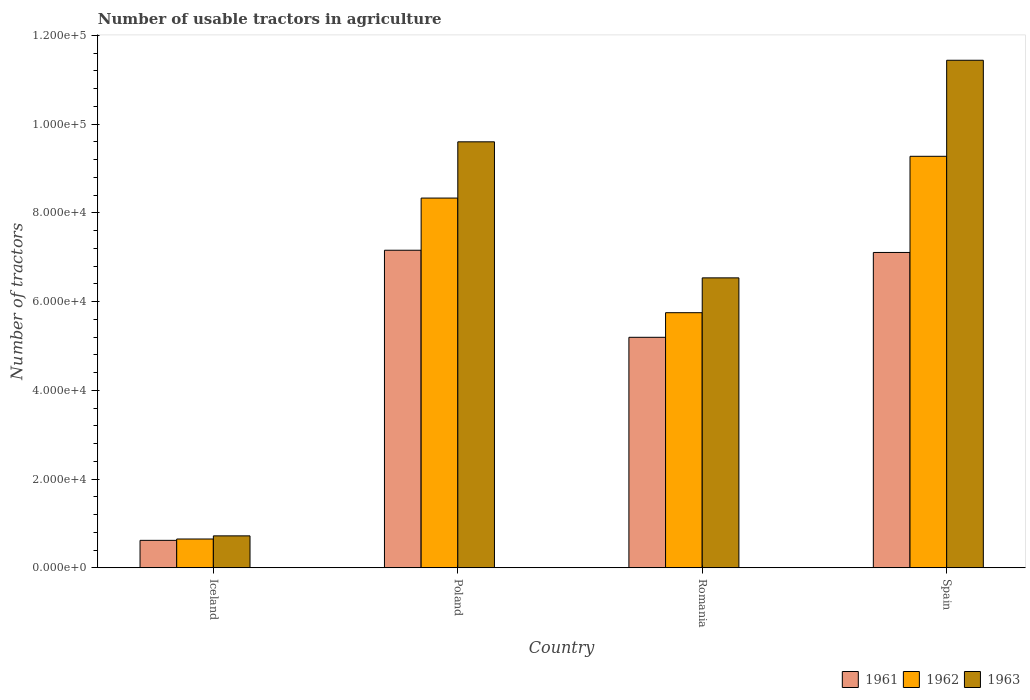How many different coloured bars are there?
Your response must be concise. 3. Are the number of bars per tick equal to the number of legend labels?
Offer a terse response. Yes. What is the label of the 4th group of bars from the left?
Provide a short and direct response. Spain. In how many cases, is the number of bars for a given country not equal to the number of legend labels?
Provide a succinct answer. 0. What is the number of usable tractors in agriculture in 1961 in Poland?
Make the answer very short. 7.16e+04. Across all countries, what is the maximum number of usable tractors in agriculture in 1961?
Your answer should be compact. 7.16e+04. Across all countries, what is the minimum number of usable tractors in agriculture in 1963?
Your response must be concise. 7187. In which country was the number of usable tractors in agriculture in 1961 maximum?
Give a very brief answer. Poland. In which country was the number of usable tractors in agriculture in 1962 minimum?
Your answer should be very brief. Iceland. What is the total number of usable tractors in agriculture in 1962 in the graph?
Offer a terse response. 2.40e+05. What is the difference between the number of usable tractors in agriculture in 1961 in Iceland and that in Romania?
Make the answer very short. -4.58e+04. What is the difference between the number of usable tractors in agriculture in 1961 in Spain and the number of usable tractors in agriculture in 1963 in Romania?
Your answer should be compact. 5726. What is the average number of usable tractors in agriculture in 1961 per country?
Offer a very short reply. 5.02e+04. What is the difference between the number of usable tractors in agriculture of/in 1963 and number of usable tractors in agriculture of/in 1962 in Poland?
Offer a terse response. 1.27e+04. In how many countries, is the number of usable tractors in agriculture in 1961 greater than 44000?
Ensure brevity in your answer.  3. What is the ratio of the number of usable tractors in agriculture in 1961 in Iceland to that in Poland?
Offer a very short reply. 0.09. Is the difference between the number of usable tractors in agriculture in 1963 in Romania and Spain greater than the difference between the number of usable tractors in agriculture in 1962 in Romania and Spain?
Offer a terse response. No. What is the difference between the highest and the second highest number of usable tractors in agriculture in 1963?
Your answer should be very brief. 1.84e+04. What is the difference between the highest and the lowest number of usable tractors in agriculture in 1962?
Provide a short and direct response. 8.63e+04. In how many countries, is the number of usable tractors in agriculture in 1961 greater than the average number of usable tractors in agriculture in 1961 taken over all countries?
Provide a short and direct response. 3. What is the difference between two consecutive major ticks on the Y-axis?
Offer a very short reply. 2.00e+04. Does the graph contain any zero values?
Make the answer very short. No. Does the graph contain grids?
Ensure brevity in your answer.  No. Where does the legend appear in the graph?
Give a very brief answer. Bottom right. What is the title of the graph?
Give a very brief answer. Number of usable tractors in agriculture. What is the label or title of the X-axis?
Provide a succinct answer. Country. What is the label or title of the Y-axis?
Your answer should be very brief. Number of tractors. What is the Number of tractors in 1961 in Iceland?
Keep it short and to the point. 6177. What is the Number of tractors in 1962 in Iceland?
Your answer should be very brief. 6479. What is the Number of tractors of 1963 in Iceland?
Make the answer very short. 7187. What is the Number of tractors of 1961 in Poland?
Give a very brief answer. 7.16e+04. What is the Number of tractors in 1962 in Poland?
Provide a succinct answer. 8.33e+04. What is the Number of tractors in 1963 in Poland?
Your response must be concise. 9.60e+04. What is the Number of tractors of 1961 in Romania?
Provide a succinct answer. 5.20e+04. What is the Number of tractors in 1962 in Romania?
Offer a terse response. 5.75e+04. What is the Number of tractors in 1963 in Romania?
Keep it short and to the point. 6.54e+04. What is the Number of tractors in 1961 in Spain?
Provide a succinct answer. 7.11e+04. What is the Number of tractors in 1962 in Spain?
Your answer should be very brief. 9.28e+04. What is the Number of tractors of 1963 in Spain?
Your answer should be very brief. 1.14e+05. Across all countries, what is the maximum Number of tractors in 1961?
Make the answer very short. 7.16e+04. Across all countries, what is the maximum Number of tractors in 1962?
Provide a succinct answer. 9.28e+04. Across all countries, what is the maximum Number of tractors in 1963?
Provide a short and direct response. 1.14e+05. Across all countries, what is the minimum Number of tractors in 1961?
Offer a terse response. 6177. Across all countries, what is the minimum Number of tractors of 1962?
Offer a very short reply. 6479. Across all countries, what is the minimum Number of tractors of 1963?
Your answer should be very brief. 7187. What is the total Number of tractors of 1961 in the graph?
Offer a very short reply. 2.01e+05. What is the total Number of tractors of 1962 in the graph?
Make the answer very short. 2.40e+05. What is the total Number of tractors of 1963 in the graph?
Your response must be concise. 2.83e+05. What is the difference between the Number of tractors in 1961 in Iceland and that in Poland?
Offer a very short reply. -6.54e+04. What is the difference between the Number of tractors of 1962 in Iceland and that in Poland?
Offer a terse response. -7.69e+04. What is the difference between the Number of tractors in 1963 in Iceland and that in Poland?
Keep it short and to the point. -8.88e+04. What is the difference between the Number of tractors of 1961 in Iceland and that in Romania?
Offer a terse response. -4.58e+04. What is the difference between the Number of tractors of 1962 in Iceland and that in Romania?
Offer a very short reply. -5.10e+04. What is the difference between the Number of tractors in 1963 in Iceland and that in Romania?
Your response must be concise. -5.82e+04. What is the difference between the Number of tractors in 1961 in Iceland and that in Spain?
Provide a succinct answer. -6.49e+04. What is the difference between the Number of tractors of 1962 in Iceland and that in Spain?
Make the answer very short. -8.63e+04. What is the difference between the Number of tractors in 1963 in Iceland and that in Spain?
Give a very brief answer. -1.07e+05. What is the difference between the Number of tractors in 1961 in Poland and that in Romania?
Ensure brevity in your answer.  1.96e+04. What is the difference between the Number of tractors of 1962 in Poland and that in Romania?
Your answer should be very brief. 2.58e+04. What is the difference between the Number of tractors of 1963 in Poland and that in Romania?
Offer a terse response. 3.07e+04. What is the difference between the Number of tractors in 1962 in Poland and that in Spain?
Your response must be concise. -9414. What is the difference between the Number of tractors of 1963 in Poland and that in Spain?
Your answer should be very brief. -1.84e+04. What is the difference between the Number of tractors in 1961 in Romania and that in Spain?
Offer a terse response. -1.91e+04. What is the difference between the Number of tractors of 1962 in Romania and that in Spain?
Ensure brevity in your answer.  -3.53e+04. What is the difference between the Number of tractors in 1963 in Romania and that in Spain?
Your answer should be compact. -4.91e+04. What is the difference between the Number of tractors in 1961 in Iceland and the Number of tractors in 1962 in Poland?
Provide a succinct answer. -7.72e+04. What is the difference between the Number of tractors in 1961 in Iceland and the Number of tractors in 1963 in Poland?
Keep it short and to the point. -8.98e+04. What is the difference between the Number of tractors of 1962 in Iceland and the Number of tractors of 1963 in Poland?
Your response must be concise. -8.95e+04. What is the difference between the Number of tractors of 1961 in Iceland and the Number of tractors of 1962 in Romania?
Your answer should be compact. -5.13e+04. What is the difference between the Number of tractors of 1961 in Iceland and the Number of tractors of 1963 in Romania?
Provide a short and direct response. -5.92e+04. What is the difference between the Number of tractors in 1962 in Iceland and the Number of tractors in 1963 in Romania?
Ensure brevity in your answer.  -5.89e+04. What is the difference between the Number of tractors in 1961 in Iceland and the Number of tractors in 1962 in Spain?
Provide a succinct answer. -8.66e+04. What is the difference between the Number of tractors in 1961 in Iceland and the Number of tractors in 1963 in Spain?
Offer a very short reply. -1.08e+05. What is the difference between the Number of tractors of 1962 in Iceland and the Number of tractors of 1963 in Spain?
Your answer should be very brief. -1.08e+05. What is the difference between the Number of tractors of 1961 in Poland and the Number of tractors of 1962 in Romania?
Your answer should be very brief. 1.41e+04. What is the difference between the Number of tractors of 1961 in Poland and the Number of tractors of 1963 in Romania?
Your answer should be compact. 6226. What is the difference between the Number of tractors of 1962 in Poland and the Number of tractors of 1963 in Romania?
Make the answer very short. 1.80e+04. What is the difference between the Number of tractors in 1961 in Poland and the Number of tractors in 1962 in Spain?
Provide a succinct answer. -2.12e+04. What is the difference between the Number of tractors in 1961 in Poland and the Number of tractors in 1963 in Spain?
Give a very brief answer. -4.28e+04. What is the difference between the Number of tractors in 1962 in Poland and the Number of tractors in 1963 in Spain?
Offer a very short reply. -3.11e+04. What is the difference between the Number of tractors of 1961 in Romania and the Number of tractors of 1962 in Spain?
Keep it short and to the point. -4.08e+04. What is the difference between the Number of tractors in 1961 in Romania and the Number of tractors in 1963 in Spain?
Make the answer very short. -6.25e+04. What is the difference between the Number of tractors of 1962 in Romania and the Number of tractors of 1963 in Spain?
Offer a very short reply. -5.69e+04. What is the average Number of tractors in 1961 per country?
Ensure brevity in your answer.  5.02e+04. What is the average Number of tractors of 1962 per country?
Offer a terse response. 6.00e+04. What is the average Number of tractors of 1963 per country?
Keep it short and to the point. 7.07e+04. What is the difference between the Number of tractors of 1961 and Number of tractors of 1962 in Iceland?
Make the answer very short. -302. What is the difference between the Number of tractors of 1961 and Number of tractors of 1963 in Iceland?
Keep it short and to the point. -1010. What is the difference between the Number of tractors of 1962 and Number of tractors of 1963 in Iceland?
Keep it short and to the point. -708. What is the difference between the Number of tractors of 1961 and Number of tractors of 1962 in Poland?
Ensure brevity in your answer.  -1.18e+04. What is the difference between the Number of tractors of 1961 and Number of tractors of 1963 in Poland?
Keep it short and to the point. -2.44e+04. What is the difference between the Number of tractors of 1962 and Number of tractors of 1963 in Poland?
Provide a short and direct response. -1.27e+04. What is the difference between the Number of tractors of 1961 and Number of tractors of 1962 in Romania?
Provide a succinct answer. -5548. What is the difference between the Number of tractors of 1961 and Number of tractors of 1963 in Romania?
Provide a short and direct response. -1.34e+04. What is the difference between the Number of tractors of 1962 and Number of tractors of 1963 in Romania?
Offer a very short reply. -7851. What is the difference between the Number of tractors in 1961 and Number of tractors in 1962 in Spain?
Provide a succinct answer. -2.17e+04. What is the difference between the Number of tractors of 1961 and Number of tractors of 1963 in Spain?
Keep it short and to the point. -4.33e+04. What is the difference between the Number of tractors of 1962 and Number of tractors of 1963 in Spain?
Provide a short and direct response. -2.17e+04. What is the ratio of the Number of tractors in 1961 in Iceland to that in Poland?
Your answer should be very brief. 0.09. What is the ratio of the Number of tractors of 1962 in Iceland to that in Poland?
Ensure brevity in your answer.  0.08. What is the ratio of the Number of tractors of 1963 in Iceland to that in Poland?
Your answer should be very brief. 0.07. What is the ratio of the Number of tractors of 1961 in Iceland to that in Romania?
Your answer should be compact. 0.12. What is the ratio of the Number of tractors of 1962 in Iceland to that in Romania?
Offer a terse response. 0.11. What is the ratio of the Number of tractors of 1963 in Iceland to that in Romania?
Make the answer very short. 0.11. What is the ratio of the Number of tractors of 1961 in Iceland to that in Spain?
Offer a very short reply. 0.09. What is the ratio of the Number of tractors in 1962 in Iceland to that in Spain?
Your answer should be very brief. 0.07. What is the ratio of the Number of tractors in 1963 in Iceland to that in Spain?
Make the answer very short. 0.06. What is the ratio of the Number of tractors of 1961 in Poland to that in Romania?
Your response must be concise. 1.38. What is the ratio of the Number of tractors of 1962 in Poland to that in Romania?
Your answer should be very brief. 1.45. What is the ratio of the Number of tractors in 1963 in Poland to that in Romania?
Give a very brief answer. 1.47. What is the ratio of the Number of tractors in 1961 in Poland to that in Spain?
Provide a short and direct response. 1.01. What is the ratio of the Number of tractors in 1962 in Poland to that in Spain?
Keep it short and to the point. 0.9. What is the ratio of the Number of tractors of 1963 in Poland to that in Spain?
Provide a succinct answer. 0.84. What is the ratio of the Number of tractors of 1961 in Romania to that in Spain?
Make the answer very short. 0.73. What is the ratio of the Number of tractors of 1962 in Romania to that in Spain?
Provide a short and direct response. 0.62. What is the ratio of the Number of tractors of 1963 in Romania to that in Spain?
Your response must be concise. 0.57. What is the difference between the highest and the second highest Number of tractors in 1962?
Your answer should be compact. 9414. What is the difference between the highest and the second highest Number of tractors of 1963?
Your response must be concise. 1.84e+04. What is the difference between the highest and the lowest Number of tractors of 1961?
Keep it short and to the point. 6.54e+04. What is the difference between the highest and the lowest Number of tractors of 1962?
Give a very brief answer. 8.63e+04. What is the difference between the highest and the lowest Number of tractors of 1963?
Your response must be concise. 1.07e+05. 